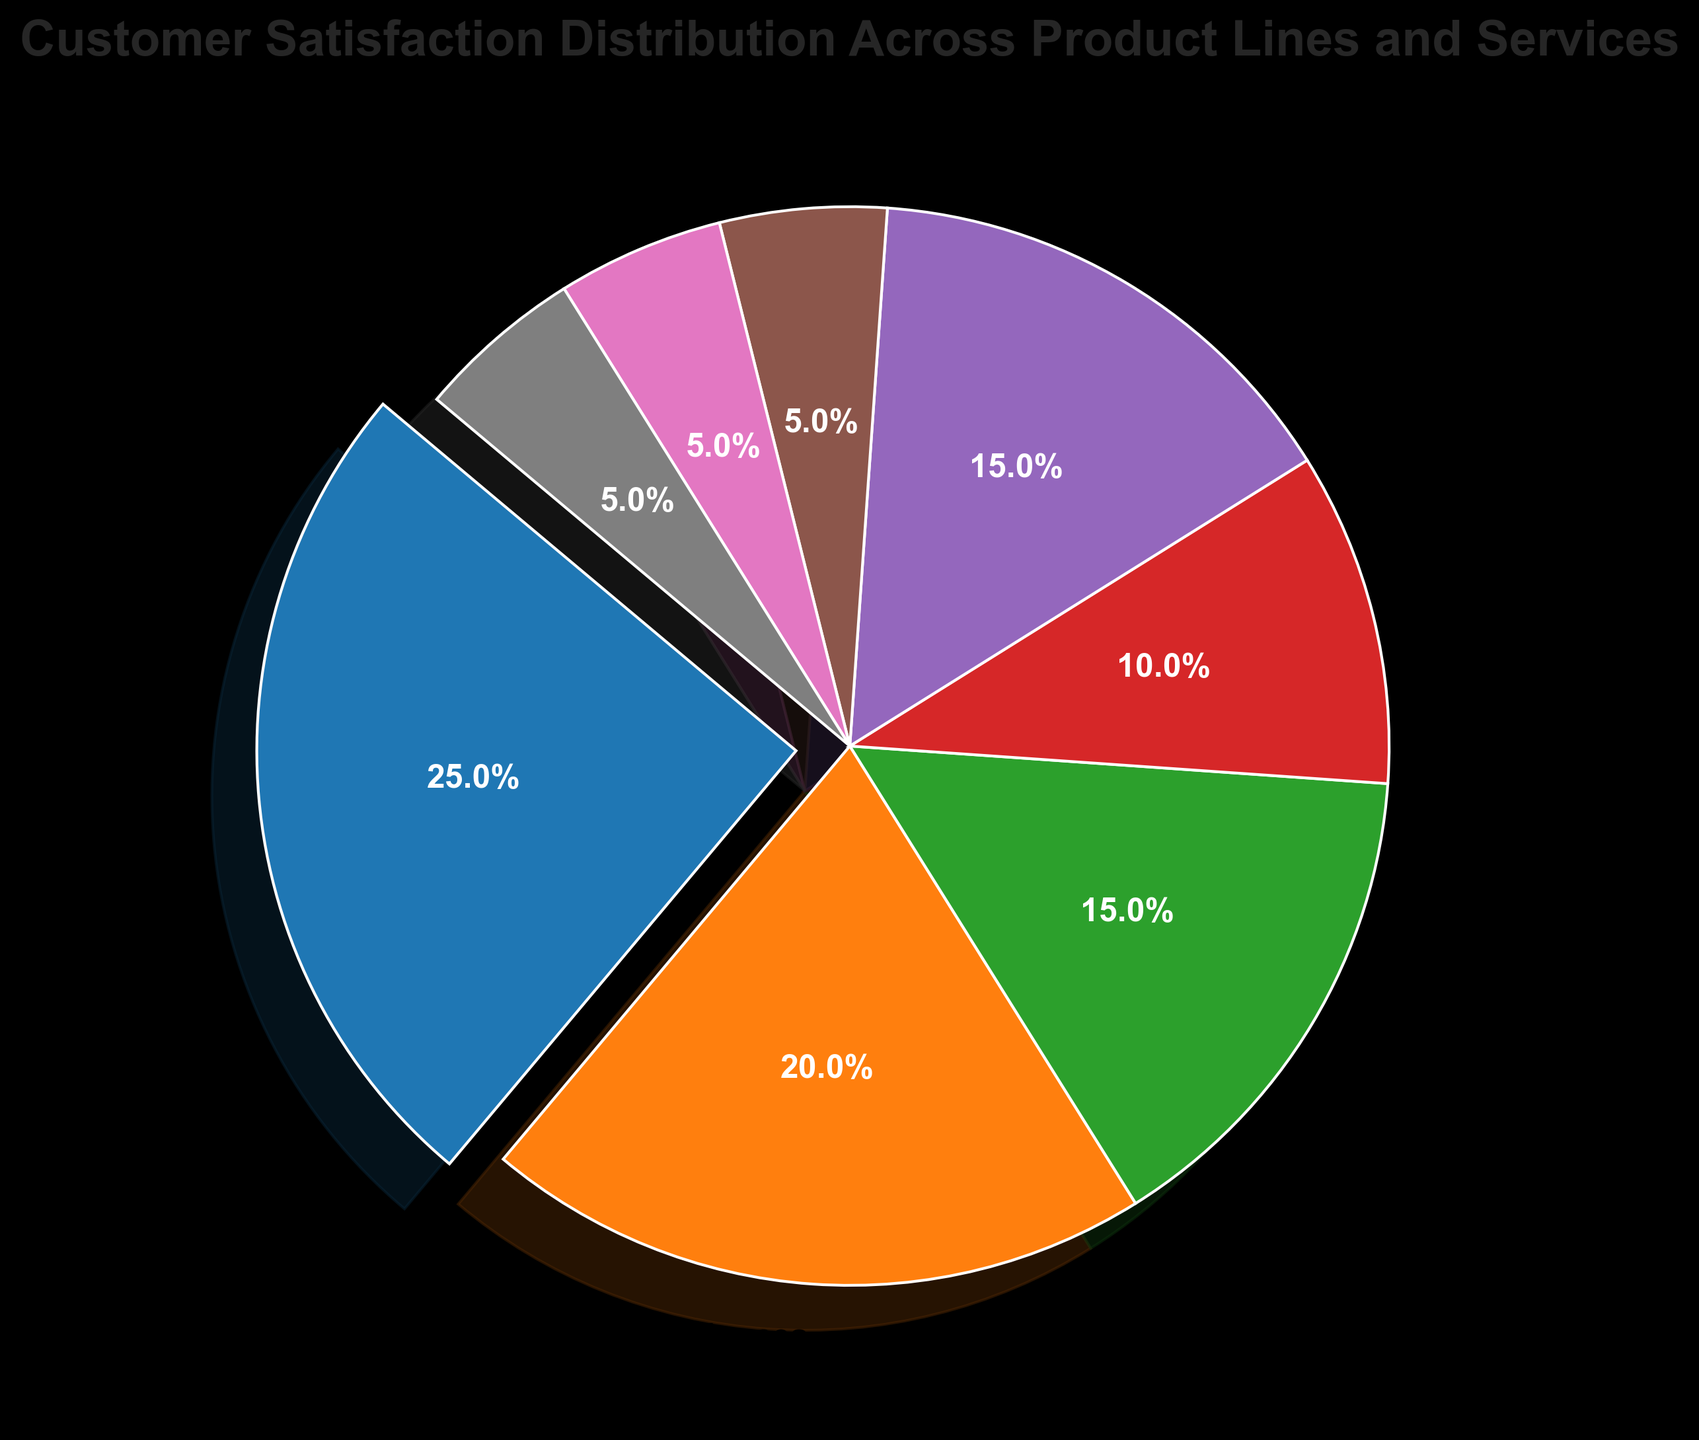What's the largest slice in the pie chart? By looking at the figure, the largest slice can be identified by its size and the label. The exploded slice emphasizes the largest segment.
Answer: Electronics Which product line has a greater customer satisfaction percentage: Clothing or Footwear? By comparing the sizes and the labels of the slices for Clothing and Footwear, you can see which one is larger. Clothing has a 15% slice, while Footwear has a 10% slice.
Answer: Clothing What's the combined customer satisfaction percentage for Books, Sports Equipment, and Toys? By adding the percentages for Books (5%), Sports Equipment (5%), and Toys (5%) together, we get 5 + 5 + 5 = 15%.
Answer: 15% How does the customer satisfaction percentage of Home Appliances compare to Furniture? By examining the pie slices for Home Appliances and Furniture, we see that both are of equal size with a 20% and 15% slice, respectively.
Answer: Home Appliances has a higher percentage What is the second largest slice in the pie chart? To find the second largest slice, identify the largest slice first (Electronics at 25%), then look for the next largest slice by size. Home Appliances is the second largest at 20%.
Answer: Home Appliances Which color represents the Furniture product line in the chart? By looking at the slice labeled Furniture and identifying its color visually, the corresponding color can be determined.
Answer: Blue If you combine the customer satisfaction percentages of Home Appliances and Clothing, what percentage do they represent together? Summing the percentages of Home Appliances (20%) and Clothing (15%) gives us 20 + 15 = 35%.
Answer: 35% What percentage is represented by the least satisfied product lines? The least satisfied product lines are those at 5% each: Sports Equipment, Books, and Toys. Adding these gives 5 + 5 + 5 = 15%.
Answer: 15% Is the combined customer satisfaction percentage of Electronics and Home Appliances greater than 40%? Sum the percentages for Electronics (25%) and Home Appliances (20%) to get 25 + 20 = 45%, which is greater than 40%.
Answer: Yes Which product line has the smallest share and what is its percentage? Multiple product lines share the smallest slice. By visually examining the chart, Sports Equipment, Books, and Toys each have a 5% slice.
Answer: Sports Equipment, Books, and Toys (5%) 